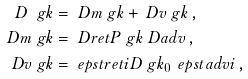Convert formula to latex. <formula><loc_0><loc_0><loc_500><loc_500>D \ g k & = \ D m \ g k + \ D v \ g k \, , \\ \ D m \ g k & = \ D r e t P \ g k \ D a d v \, , \\ \ D v \ g k & = \ e p s t r e t i D \ g k _ { 0 } \, \ e p s t a d v i \, ,</formula> 